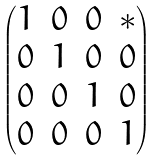Convert formula to latex. <formula><loc_0><loc_0><loc_500><loc_500>\begin{pmatrix} 1 & 0 & 0 & * \\ 0 & 1 & 0 & 0 \\ 0 & 0 & 1 & 0 \\ 0 & 0 & 0 & 1 \end{pmatrix}</formula> 